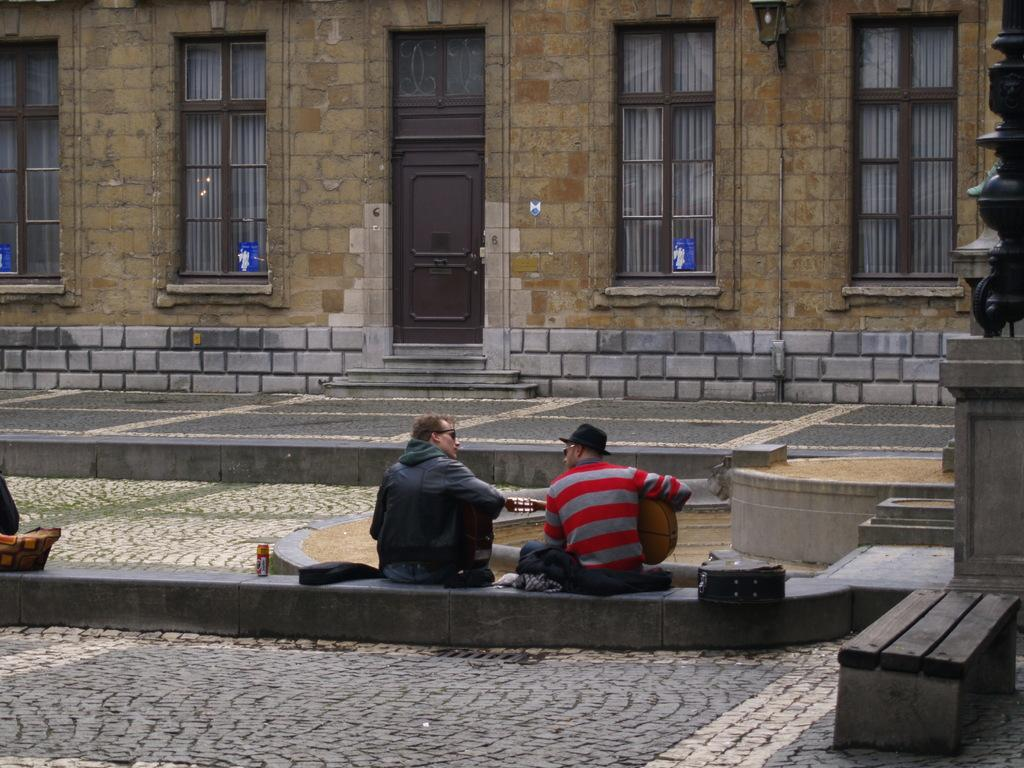How many people are sitting in the image? There are two men sitting in the image. What is one of the men holding? One man is holding a guitar. What can be seen in the background of the image? There is a building and a door in the background of the image. What type of lettuce is being used as a prop by the men in the image? There is no lettuce present in the image; it features two men, one of whom is holding a guitar, and a background with a building and a door. 